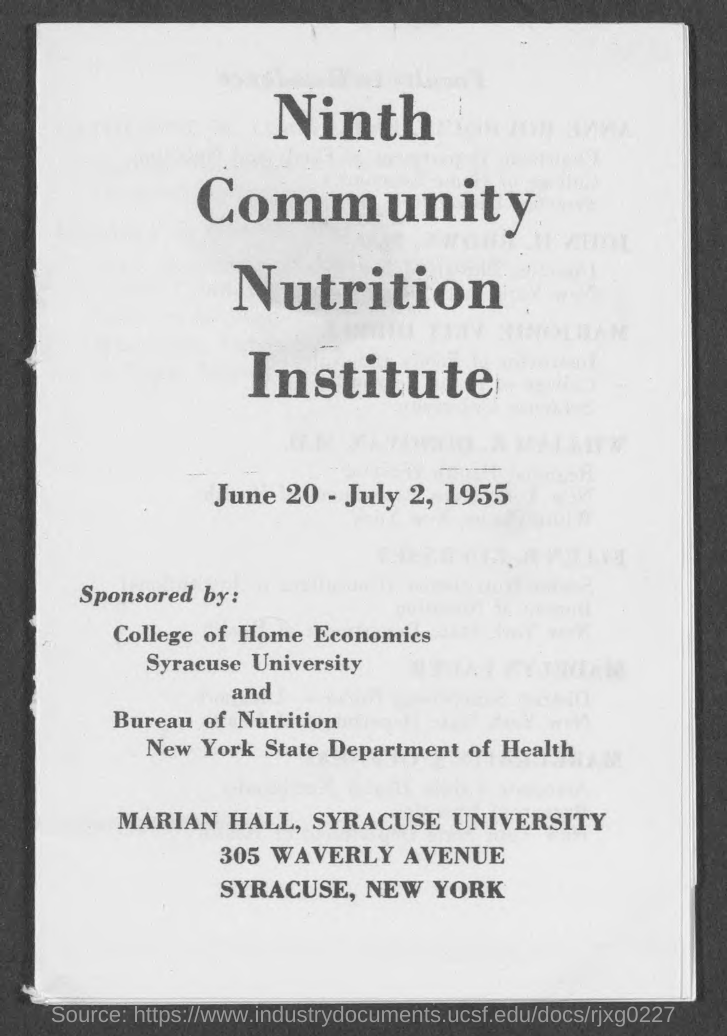Draw attention to some important aspects in this diagram. The program was conducted from June 20 to July 2, 1955. The title of the program is the Ninth Community Nutrition Institute. Syracuse University conducts the program. The "Ninth Community Nutrition Institute" program is sponsored by Syracuse University's College of Home Economics and the Bureau of Nutrition of the New York State Department of Health. The program will be held in Marian Hall. 